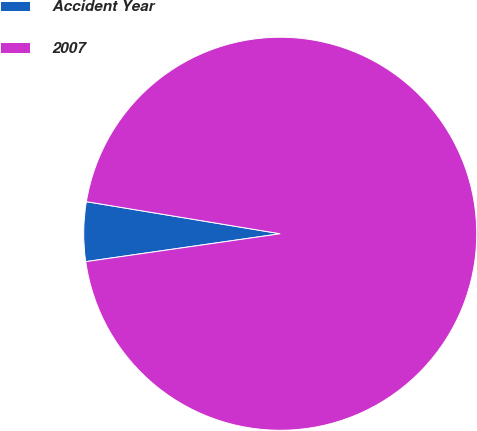Convert chart to OTSL. <chart><loc_0><loc_0><loc_500><loc_500><pie_chart><fcel>Accident Year<fcel>2007<nl><fcel>4.88%<fcel>95.12%<nl></chart> 